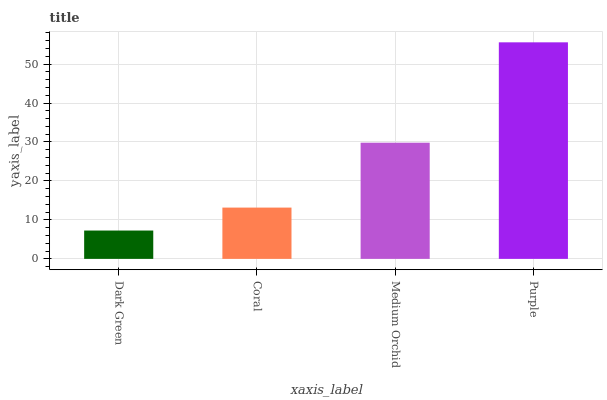Is Dark Green the minimum?
Answer yes or no. Yes. Is Purple the maximum?
Answer yes or no. Yes. Is Coral the minimum?
Answer yes or no. No. Is Coral the maximum?
Answer yes or no. No. Is Coral greater than Dark Green?
Answer yes or no. Yes. Is Dark Green less than Coral?
Answer yes or no. Yes. Is Dark Green greater than Coral?
Answer yes or no. No. Is Coral less than Dark Green?
Answer yes or no. No. Is Medium Orchid the high median?
Answer yes or no. Yes. Is Coral the low median?
Answer yes or no. Yes. Is Coral the high median?
Answer yes or no. No. Is Purple the low median?
Answer yes or no. No. 